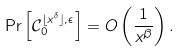<formula> <loc_0><loc_0><loc_500><loc_500>\Pr \left [ \mathcal { C } _ { 0 } ^ { \lfloor x ^ { \delta } \rfloor , \epsilon } \right ] = O \left ( \frac { 1 } { x ^ { \beta } } \right ) .</formula> 